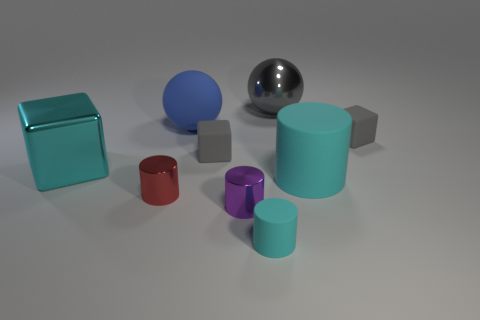The ball that is on the right side of the sphere to the left of the metal sphere is made of what material?
Ensure brevity in your answer.  Metal. The tiny cyan rubber thing in front of the shiny object on the right side of the rubber cylinder in front of the tiny red shiny object is what shape?
Your response must be concise. Cylinder. What material is the tiny purple object that is the same shape as the small red object?
Provide a short and direct response. Metal. What number of green blocks are there?
Provide a short and direct response. 0. What is the shape of the small matte object that is in front of the big cube?
Provide a succinct answer. Cylinder. The ball that is left of the gray matte thing on the left side of the cyan cylinder that is to the left of the large cyan matte cylinder is what color?
Make the answer very short. Blue. There is a tiny object that is the same material as the tiny purple cylinder; what shape is it?
Your response must be concise. Cylinder. Is the number of tiny gray matte things less than the number of tiny purple cylinders?
Provide a succinct answer. No. Does the big cube have the same material as the tiny red cylinder?
Make the answer very short. Yes. What number of other objects are there of the same color as the large matte cylinder?
Provide a short and direct response. 2. 